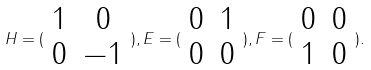<formula> <loc_0><loc_0><loc_500><loc_500>H = ( \begin{array} { c c } 1 & 0 \\ 0 & - 1 \end{array} ) , E = ( \begin{array} { c c } 0 & 1 \\ 0 & 0 \end{array} ) , F = ( \begin{array} { c c } 0 & 0 \\ 1 & 0 \end{array} ) .</formula> 